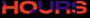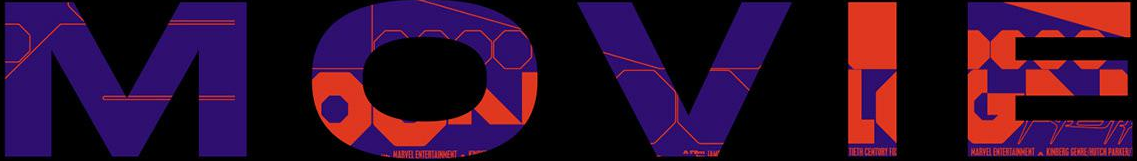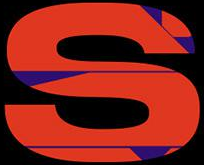Read the text from these images in sequence, separated by a semicolon. HOURS; MOVIE; S 